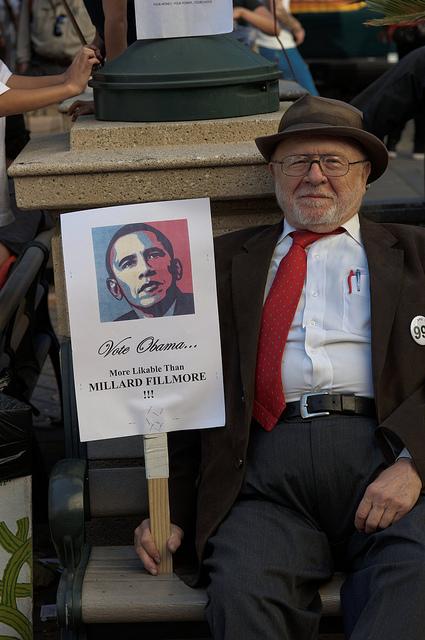Is that President Fillmore?
Quick response, please. No. Which politician is the sign in favor of?
Write a very short answer. Obama. What is the color of the tie?
Give a very brief answer. Red. 